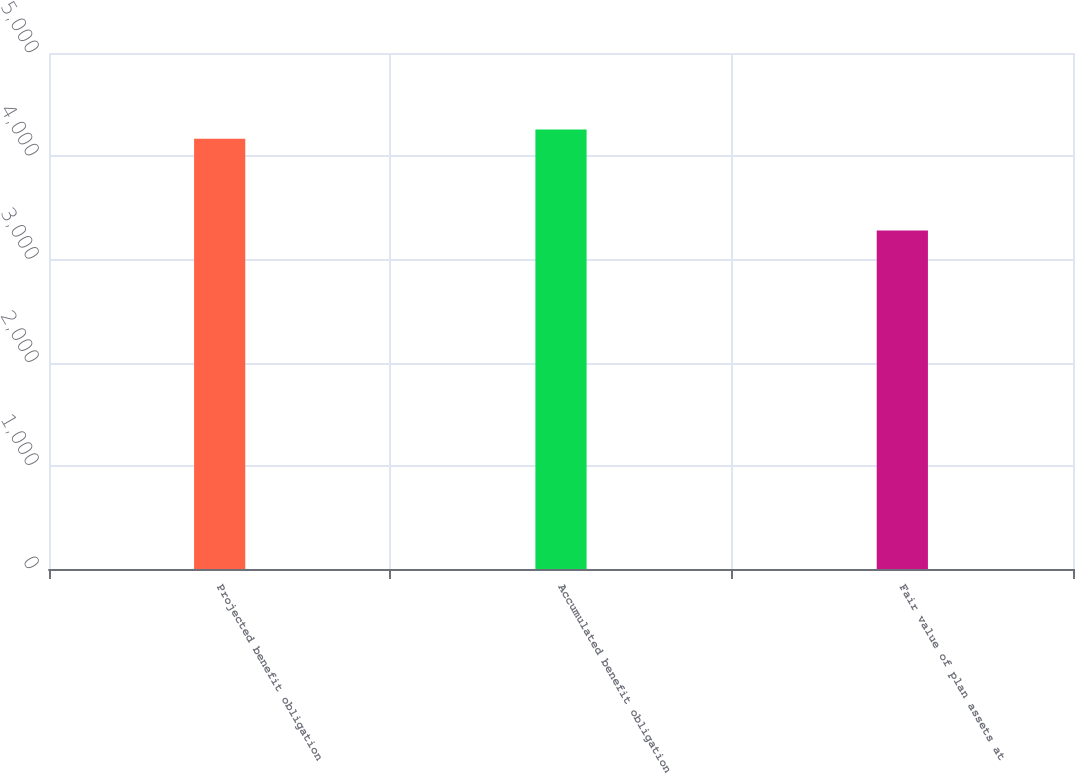Convert chart. <chart><loc_0><loc_0><loc_500><loc_500><bar_chart><fcel>Projected benefit obligation<fcel>Accumulated benefit obligation<fcel>Fair value of plan assets at<nl><fcel>4169<fcel>4257.9<fcel>3280<nl></chart> 